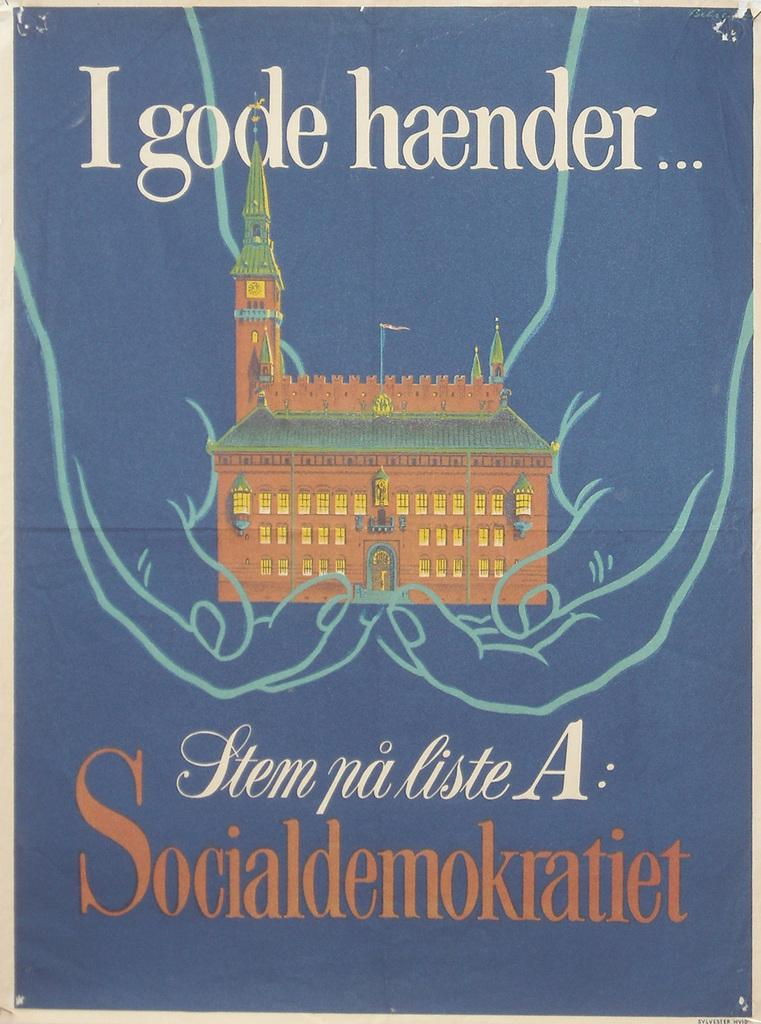<image>
Share a concise interpretation of the image provided. Cover showing a building and the words "Socialdemokratiet" on the bottom. 